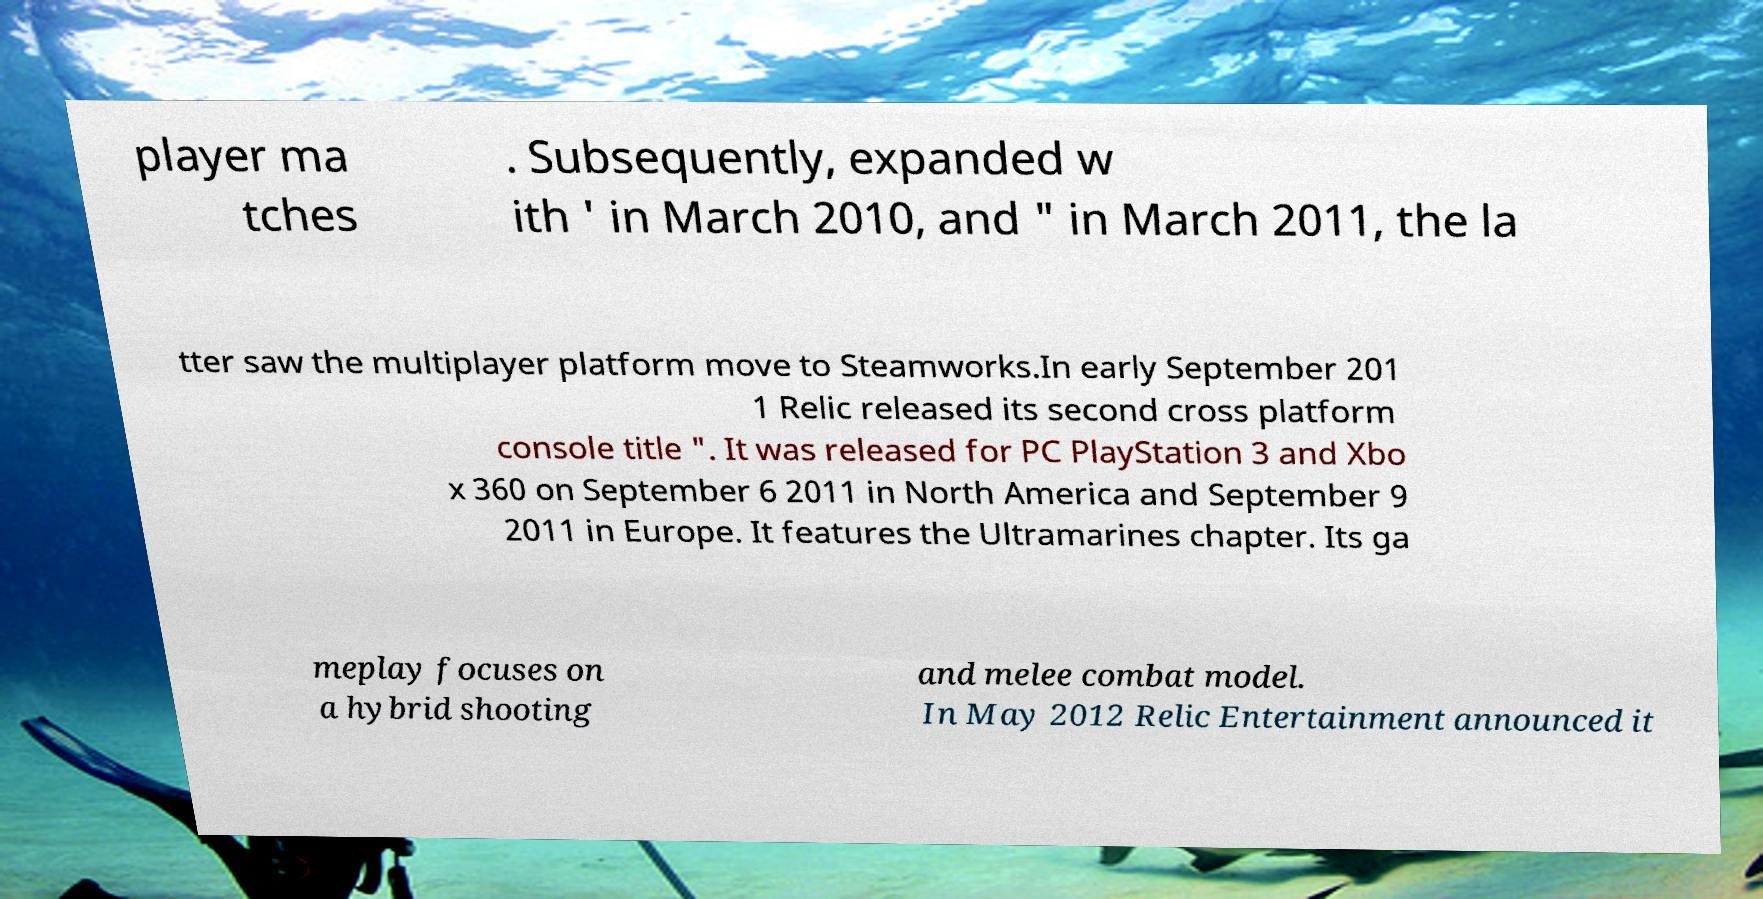Could you assist in decoding the text presented in this image and type it out clearly? player ma tches . Subsequently, expanded w ith ' in March 2010, and " in March 2011, the la tter saw the multiplayer platform move to Steamworks.In early September 201 1 Relic released its second cross platform console title ". It was released for PC PlayStation 3 and Xbo x 360 on September 6 2011 in North America and September 9 2011 in Europe. It features the Ultramarines chapter. Its ga meplay focuses on a hybrid shooting and melee combat model. In May 2012 Relic Entertainment announced it 